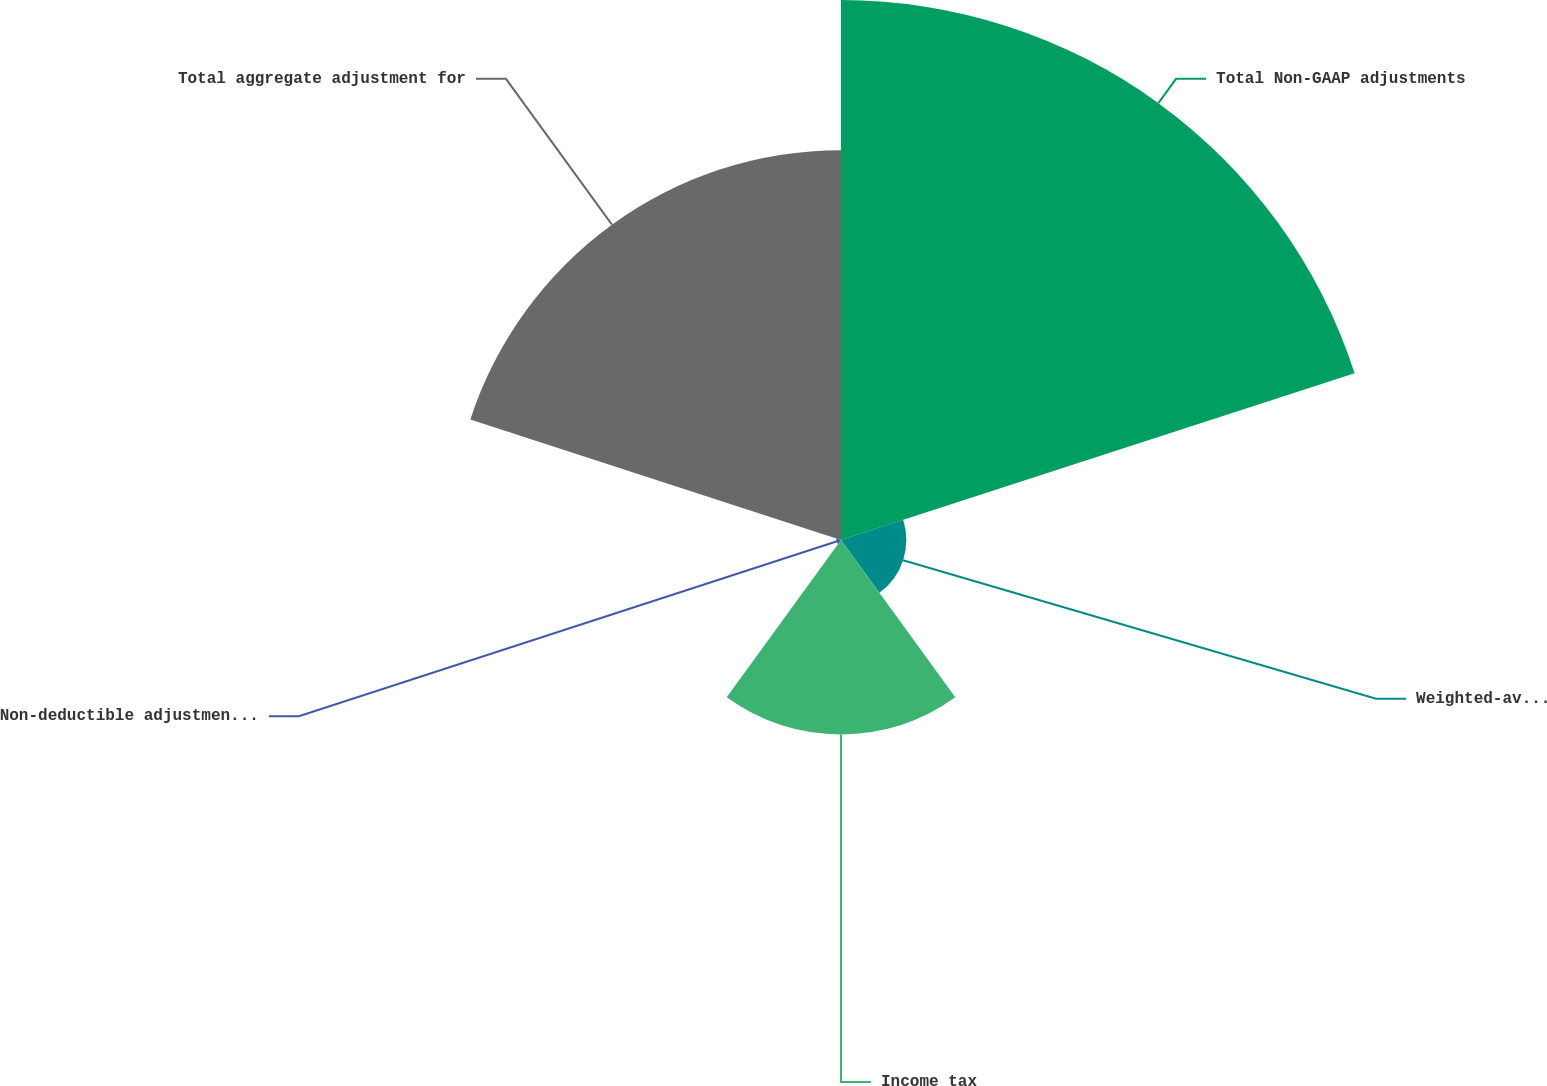<chart> <loc_0><loc_0><loc_500><loc_500><pie_chart><fcel>Total Non-GAAP adjustments<fcel>Weighted-average statutory<fcel>Income tax<fcel>Non-deductible adjustments and<fcel>Total aggregate adjustment for<nl><fcel>45.21%<fcel>5.47%<fcel>16.28%<fcel>0.41%<fcel>32.63%<nl></chart> 